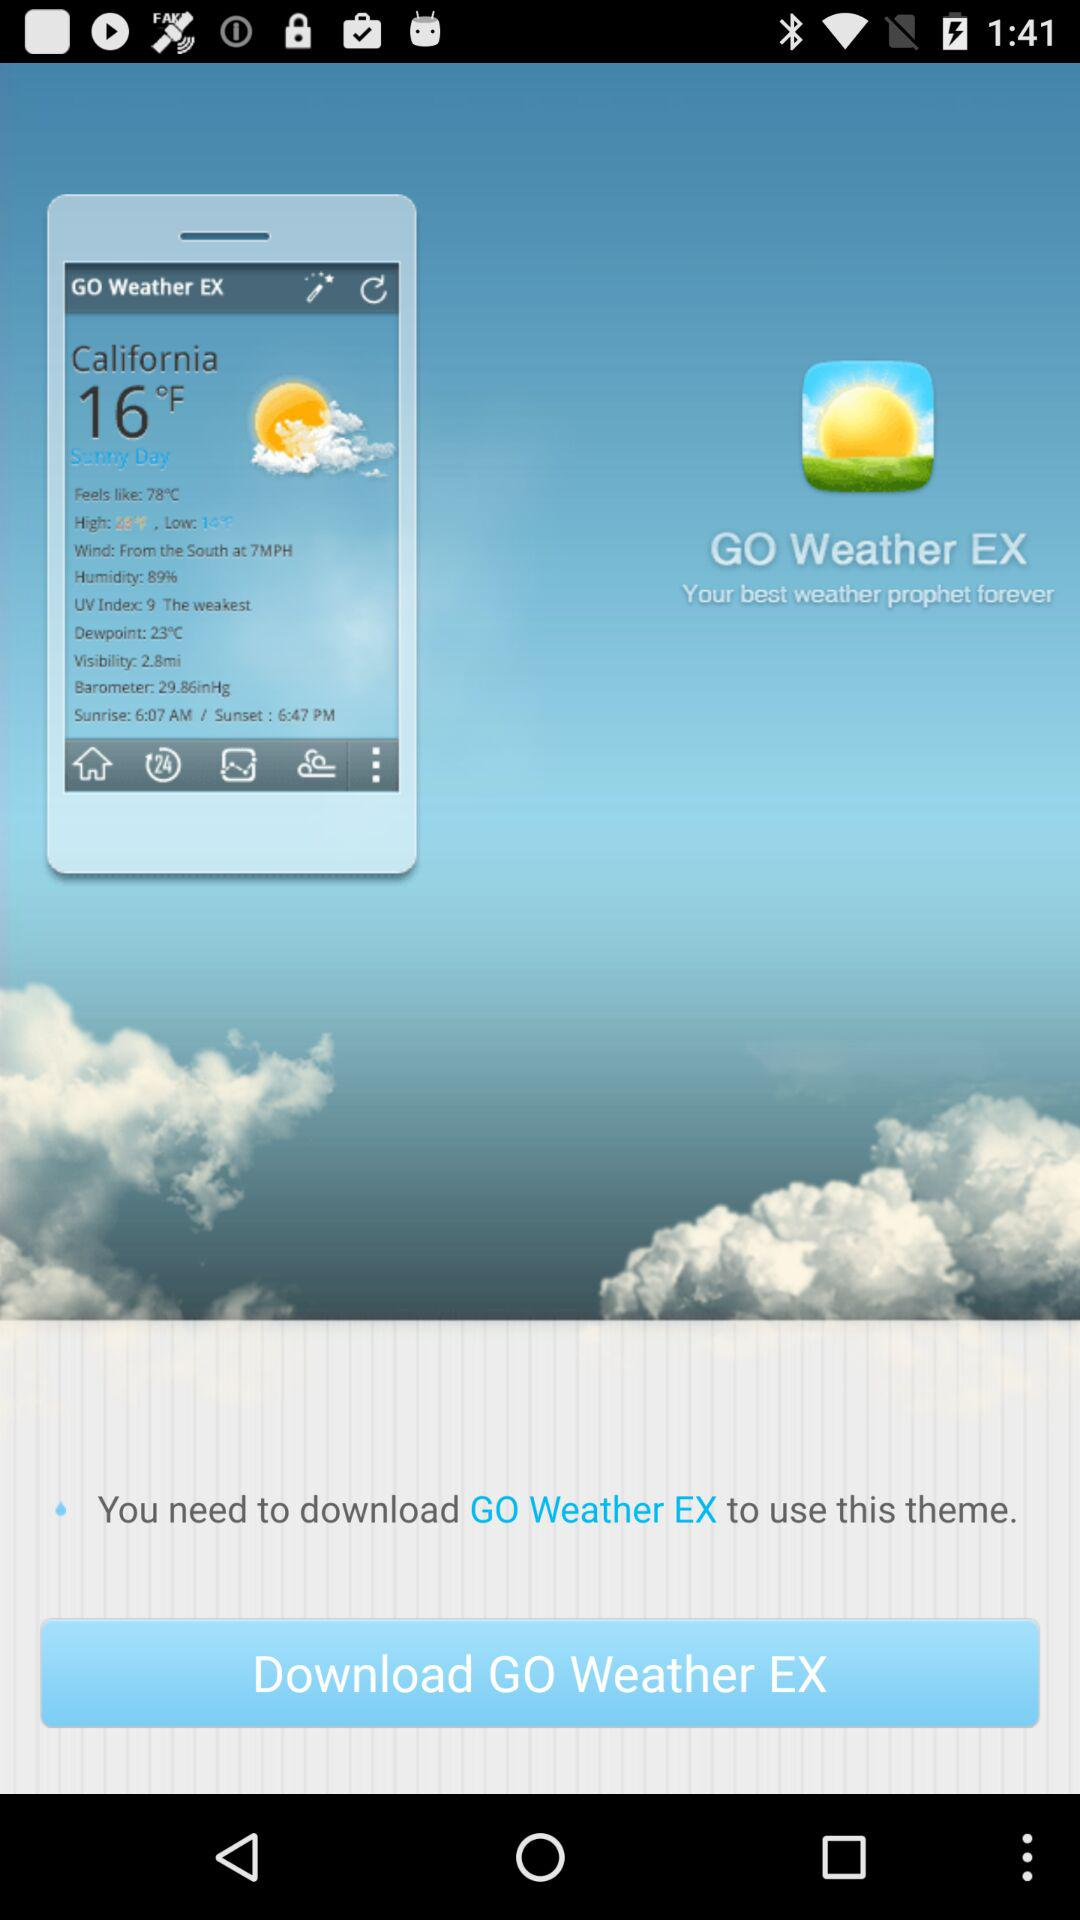What is the location? The location is California. 